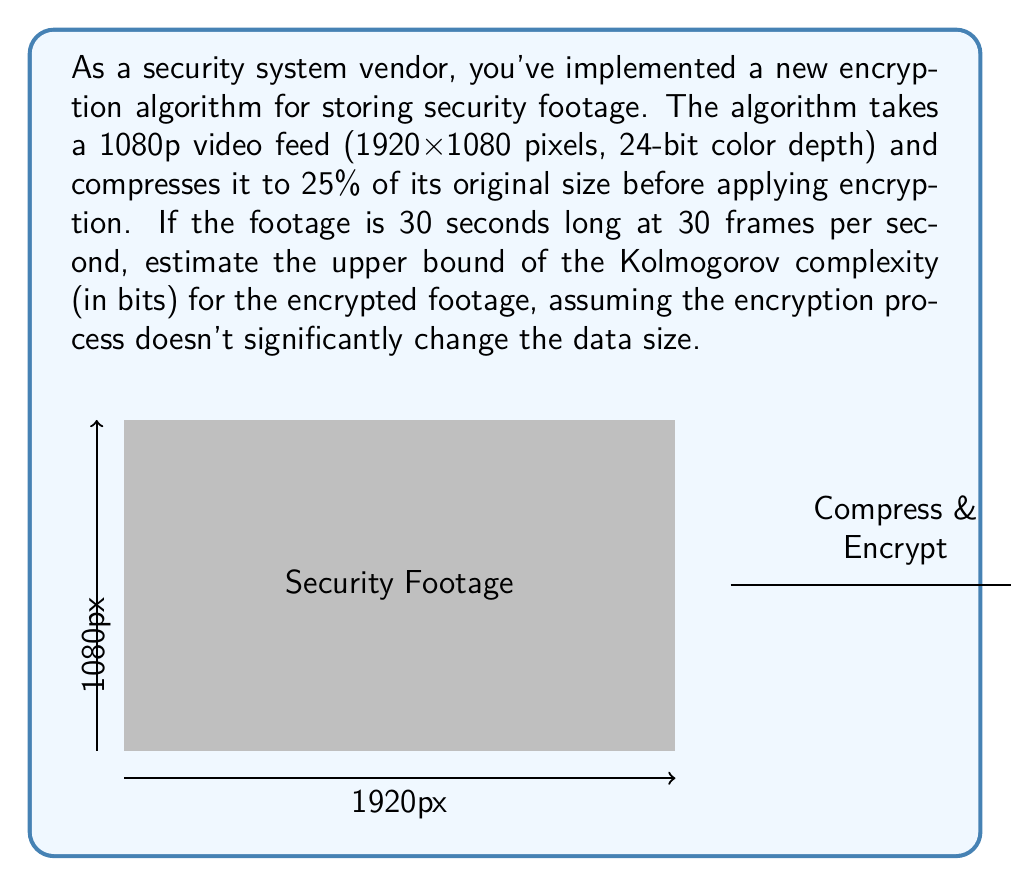Give your solution to this math problem. Let's approach this step-by-step:

1) First, calculate the size of the original video:
   - Resolution: 1920 x 1080 pixels
   - Color depth: 24 bits per pixel
   - Duration: 30 seconds
   - Frame rate: 30 fps

   Size per frame = $1920 \times 1080 \times 24 = 49,766,400$ bits
   Total frames = $30 \text{ seconds} \times 30 \text{ fps} = 900$ frames
   
   Total size = $49,766,400 \times 900 = 44,789,760,000$ bits

2) The compression reduces this to 25%:
   Compressed size = $44,789,760,000 \times 0.25 = 11,197,440,000$ bits

3) The Kolmogorov complexity of a string is upper-bounded by the length of its shortest description plus a constant. In this case, the encrypted and compressed footage is our shortest known description.

4) The encryption process doesn't significantly change the data size, so we can use the compressed size as our upper bound estimate.

Therefore, the upper bound of the Kolmogorov complexity is approximately 11,197,440,000 bits.

Note: This is a conservative upper bound. The actual Kolmogorov complexity could be lower if there are more efficient ways to describe the video content.
Answer: $11,197,440,000$ bits 